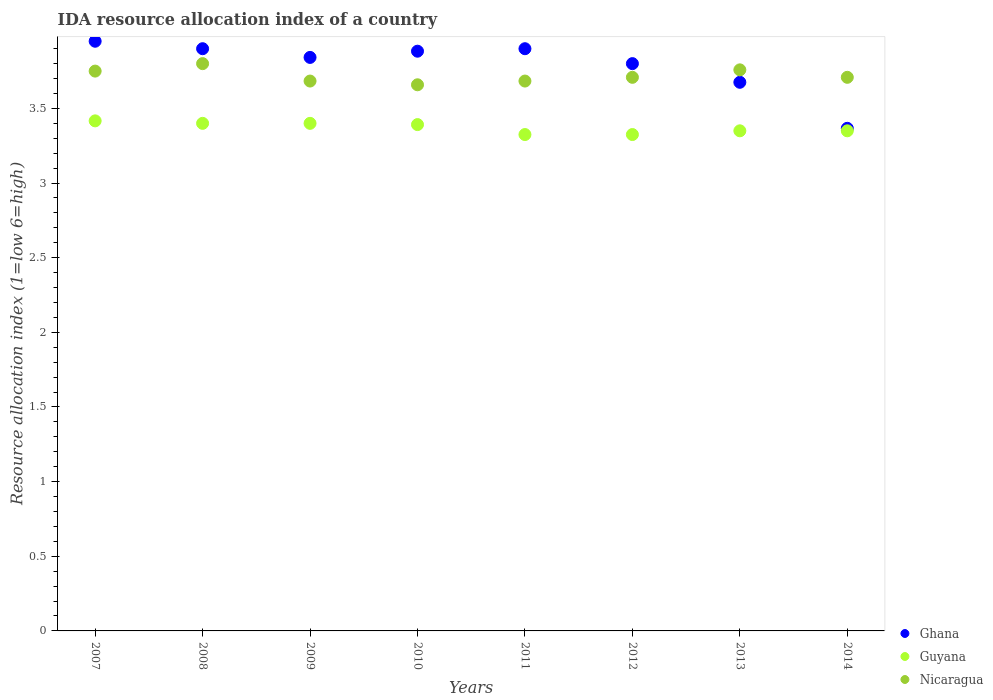Is the number of dotlines equal to the number of legend labels?
Provide a succinct answer. Yes. What is the IDA resource allocation index in Ghana in 2007?
Give a very brief answer. 3.95. Across all years, what is the maximum IDA resource allocation index in Ghana?
Make the answer very short. 3.95. Across all years, what is the minimum IDA resource allocation index in Guyana?
Keep it short and to the point. 3.33. In which year was the IDA resource allocation index in Nicaragua maximum?
Keep it short and to the point. 2008. In which year was the IDA resource allocation index in Nicaragua minimum?
Offer a very short reply. 2010. What is the total IDA resource allocation index in Nicaragua in the graph?
Provide a succinct answer. 29.75. What is the difference between the IDA resource allocation index in Nicaragua in 2012 and that in 2013?
Keep it short and to the point. -0.05. What is the difference between the IDA resource allocation index in Nicaragua in 2011 and the IDA resource allocation index in Ghana in 2013?
Offer a very short reply. 0.01. What is the average IDA resource allocation index in Nicaragua per year?
Make the answer very short. 3.72. In the year 2007, what is the difference between the IDA resource allocation index in Guyana and IDA resource allocation index in Nicaragua?
Your answer should be compact. -0.33. In how many years, is the IDA resource allocation index in Nicaragua greater than 3.2?
Provide a short and direct response. 8. What is the ratio of the IDA resource allocation index in Guyana in 2010 to that in 2011?
Give a very brief answer. 1.02. Is the IDA resource allocation index in Ghana in 2008 less than that in 2012?
Your answer should be compact. No. What is the difference between the highest and the second highest IDA resource allocation index in Nicaragua?
Offer a terse response. 0.04. What is the difference between the highest and the lowest IDA resource allocation index in Guyana?
Provide a short and direct response. 0.09. In how many years, is the IDA resource allocation index in Guyana greater than the average IDA resource allocation index in Guyana taken over all years?
Offer a very short reply. 4. Is it the case that in every year, the sum of the IDA resource allocation index in Nicaragua and IDA resource allocation index in Guyana  is greater than the IDA resource allocation index in Ghana?
Make the answer very short. Yes. Is the IDA resource allocation index in Nicaragua strictly greater than the IDA resource allocation index in Ghana over the years?
Your answer should be compact. No. Is the IDA resource allocation index in Nicaragua strictly less than the IDA resource allocation index in Guyana over the years?
Provide a short and direct response. No. How many dotlines are there?
Ensure brevity in your answer.  3. Are the values on the major ticks of Y-axis written in scientific E-notation?
Keep it short and to the point. No. Does the graph contain any zero values?
Ensure brevity in your answer.  No. Where does the legend appear in the graph?
Your answer should be compact. Bottom right. How are the legend labels stacked?
Keep it short and to the point. Vertical. What is the title of the graph?
Your answer should be compact. IDA resource allocation index of a country. What is the label or title of the X-axis?
Your answer should be very brief. Years. What is the label or title of the Y-axis?
Provide a short and direct response. Resource allocation index (1=low 6=high). What is the Resource allocation index (1=low 6=high) of Ghana in 2007?
Your response must be concise. 3.95. What is the Resource allocation index (1=low 6=high) of Guyana in 2007?
Ensure brevity in your answer.  3.42. What is the Resource allocation index (1=low 6=high) of Nicaragua in 2007?
Your response must be concise. 3.75. What is the Resource allocation index (1=low 6=high) of Ghana in 2008?
Provide a succinct answer. 3.9. What is the Resource allocation index (1=low 6=high) in Guyana in 2008?
Offer a terse response. 3.4. What is the Resource allocation index (1=low 6=high) of Nicaragua in 2008?
Your answer should be very brief. 3.8. What is the Resource allocation index (1=low 6=high) of Ghana in 2009?
Offer a very short reply. 3.84. What is the Resource allocation index (1=low 6=high) of Nicaragua in 2009?
Give a very brief answer. 3.68. What is the Resource allocation index (1=low 6=high) in Ghana in 2010?
Make the answer very short. 3.88. What is the Resource allocation index (1=low 6=high) of Guyana in 2010?
Keep it short and to the point. 3.39. What is the Resource allocation index (1=low 6=high) of Nicaragua in 2010?
Offer a terse response. 3.66. What is the Resource allocation index (1=low 6=high) of Ghana in 2011?
Offer a terse response. 3.9. What is the Resource allocation index (1=low 6=high) in Guyana in 2011?
Provide a short and direct response. 3.33. What is the Resource allocation index (1=low 6=high) in Nicaragua in 2011?
Offer a terse response. 3.68. What is the Resource allocation index (1=low 6=high) of Ghana in 2012?
Your answer should be very brief. 3.8. What is the Resource allocation index (1=low 6=high) of Guyana in 2012?
Ensure brevity in your answer.  3.33. What is the Resource allocation index (1=low 6=high) in Nicaragua in 2012?
Offer a very short reply. 3.71. What is the Resource allocation index (1=low 6=high) of Ghana in 2013?
Offer a terse response. 3.67. What is the Resource allocation index (1=low 6=high) in Guyana in 2013?
Keep it short and to the point. 3.35. What is the Resource allocation index (1=low 6=high) in Nicaragua in 2013?
Provide a short and direct response. 3.76. What is the Resource allocation index (1=low 6=high) of Ghana in 2014?
Your answer should be very brief. 3.37. What is the Resource allocation index (1=low 6=high) of Guyana in 2014?
Your answer should be very brief. 3.35. What is the Resource allocation index (1=low 6=high) of Nicaragua in 2014?
Your answer should be very brief. 3.71. Across all years, what is the maximum Resource allocation index (1=low 6=high) of Ghana?
Offer a very short reply. 3.95. Across all years, what is the maximum Resource allocation index (1=low 6=high) in Guyana?
Your response must be concise. 3.42. Across all years, what is the minimum Resource allocation index (1=low 6=high) in Ghana?
Provide a succinct answer. 3.37. Across all years, what is the minimum Resource allocation index (1=low 6=high) of Guyana?
Provide a short and direct response. 3.33. Across all years, what is the minimum Resource allocation index (1=low 6=high) in Nicaragua?
Offer a terse response. 3.66. What is the total Resource allocation index (1=low 6=high) of Ghana in the graph?
Ensure brevity in your answer.  30.32. What is the total Resource allocation index (1=low 6=high) in Guyana in the graph?
Offer a very short reply. 26.96. What is the total Resource allocation index (1=low 6=high) in Nicaragua in the graph?
Your answer should be very brief. 29.75. What is the difference between the Resource allocation index (1=low 6=high) of Guyana in 2007 and that in 2008?
Provide a succinct answer. 0.02. What is the difference between the Resource allocation index (1=low 6=high) in Ghana in 2007 and that in 2009?
Provide a short and direct response. 0.11. What is the difference between the Resource allocation index (1=low 6=high) of Guyana in 2007 and that in 2009?
Offer a very short reply. 0.02. What is the difference between the Resource allocation index (1=low 6=high) in Nicaragua in 2007 and that in 2009?
Your answer should be very brief. 0.07. What is the difference between the Resource allocation index (1=low 6=high) in Ghana in 2007 and that in 2010?
Keep it short and to the point. 0.07. What is the difference between the Resource allocation index (1=low 6=high) in Guyana in 2007 and that in 2010?
Offer a terse response. 0.03. What is the difference between the Resource allocation index (1=low 6=high) of Nicaragua in 2007 and that in 2010?
Make the answer very short. 0.09. What is the difference between the Resource allocation index (1=low 6=high) in Guyana in 2007 and that in 2011?
Give a very brief answer. 0.09. What is the difference between the Resource allocation index (1=low 6=high) in Nicaragua in 2007 and that in 2011?
Your response must be concise. 0.07. What is the difference between the Resource allocation index (1=low 6=high) in Guyana in 2007 and that in 2012?
Your answer should be very brief. 0.09. What is the difference between the Resource allocation index (1=low 6=high) in Nicaragua in 2007 and that in 2012?
Your response must be concise. 0.04. What is the difference between the Resource allocation index (1=low 6=high) in Ghana in 2007 and that in 2013?
Ensure brevity in your answer.  0.28. What is the difference between the Resource allocation index (1=low 6=high) of Guyana in 2007 and that in 2013?
Offer a terse response. 0.07. What is the difference between the Resource allocation index (1=low 6=high) of Nicaragua in 2007 and that in 2013?
Keep it short and to the point. -0.01. What is the difference between the Resource allocation index (1=low 6=high) in Ghana in 2007 and that in 2014?
Your response must be concise. 0.58. What is the difference between the Resource allocation index (1=low 6=high) in Guyana in 2007 and that in 2014?
Your answer should be very brief. 0.07. What is the difference between the Resource allocation index (1=low 6=high) of Nicaragua in 2007 and that in 2014?
Provide a short and direct response. 0.04. What is the difference between the Resource allocation index (1=low 6=high) of Ghana in 2008 and that in 2009?
Give a very brief answer. 0.06. What is the difference between the Resource allocation index (1=low 6=high) in Guyana in 2008 and that in 2009?
Provide a short and direct response. 0. What is the difference between the Resource allocation index (1=low 6=high) of Nicaragua in 2008 and that in 2009?
Provide a succinct answer. 0.12. What is the difference between the Resource allocation index (1=low 6=high) of Ghana in 2008 and that in 2010?
Provide a succinct answer. 0.02. What is the difference between the Resource allocation index (1=low 6=high) in Guyana in 2008 and that in 2010?
Offer a terse response. 0.01. What is the difference between the Resource allocation index (1=low 6=high) of Nicaragua in 2008 and that in 2010?
Ensure brevity in your answer.  0.14. What is the difference between the Resource allocation index (1=low 6=high) in Guyana in 2008 and that in 2011?
Provide a short and direct response. 0.07. What is the difference between the Resource allocation index (1=low 6=high) of Nicaragua in 2008 and that in 2011?
Your answer should be compact. 0.12. What is the difference between the Resource allocation index (1=low 6=high) in Guyana in 2008 and that in 2012?
Ensure brevity in your answer.  0.07. What is the difference between the Resource allocation index (1=low 6=high) of Nicaragua in 2008 and that in 2012?
Keep it short and to the point. 0.09. What is the difference between the Resource allocation index (1=low 6=high) in Ghana in 2008 and that in 2013?
Give a very brief answer. 0.23. What is the difference between the Resource allocation index (1=low 6=high) of Nicaragua in 2008 and that in 2013?
Offer a very short reply. 0.04. What is the difference between the Resource allocation index (1=low 6=high) of Ghana in 2008 and that in 2014?
Ensure brevity in your answer.  0.53. What is the difference between the Resource allocation index (1=low 6=high) of Guyana in 2008 and that in 2014?
Offer a very short reply. 0.05. What is the difference between the Resource allocation index (1=low 6=high) in Nicaragua in 2008 and that in 2014?
Give a very brief answer. 0.09. What is the difference between the Resource allocation index (1=low 6=high) of Ghana in 2009 and that in 2010?
Keep it short and to the point. -0.04. What is the difference between the Resource allocation index (1=low 6=high) of Guyana in 2009 and that in 2010?
Keep it short and to the point. 0.01. What is the difference between the Resource allocation index (1=low 6=high) of Nicaragua in 2009 and that in 2010?
Your answer should be compact. 0.03. What is the difference between the Resource allocation index (1=low 6=high) of Ghana in 2009 and that in 2011?
Your answer should be compact. -0.06. What is the difference between the Resource allocation index (1=low 6=high) in Guyana in 2009 and that in 2011?
Offer a very short reply. 0.07. What is the difference between the Resource allocation index (1=low 6=high) in Ghana in 2009 and that in 2012?
Offer a very short reply. 0.04. What is the difference between the Resource allocation index (1=low 6=high) of Guyana in 2009 and that in 2012?
Give a very brief answer. 0.07. What is the difference between the Resource allocation index (1=low 6=high) of Nicaragua in 2009 and that in 2012?
Provide a short and direct response. -0.03. What is the difference between the Resource allocation index (1=low 6=high) in Ghana in 2009 and that in 2013?
Provide a succinct answer. 0.17. What is the difference between the Resource allocation index (1=low 6=high) in Guyana in 2009 and that in 2013?
Your response must be concise. 0.05. What is the difference between the Resource allocation index (1=low 6=high) in Nicaragua in 2009 and that in 2013?
Your answer should be compact. -0.07. What is the difference between the Resource allocation index (1=low 6=high) in Ghana in 2009 and that in 2014?
Give a very brief answer. 0.47. What is the difference between the Resource allocation index (1=low 6=high) in Guyana in 2009 and that in 2014?
Your response must be concise. 0.05. What is the difference between the Resource allocation index (1=low 6=high) in Nicaragua in 2009 and that in 2014?
Provide a succinct answer. -0.03. What is the difference between the Resource allocation index (1=low 6=high) in Ghana in 2010 and that in 2011?
Your response must be concise. -0.02. What is the difference between the Resource allocation index (1=low 6=high) of Guyana in 2010 and that in 2011?
Give a very brief answer. 0.07. What is the difference between the Resource allocation index (1=low 6=high) in Nicaragua in 2010 and that in 2011?
Keep it short and to the point. -0.03. What is the difference between the Resource allocation index (1=low 6=high) in Ghana in 2010 and that in 2012?
Provide a short and direct response. 0.08. What is the difference between the Resource allocation index (1=low 6=high) of Guyana in 2010 and that in 2012?
Offer a very short reply. 0.07. What is the difference between the Resource allocation index (1=low 6=high) of Nicaragua in 2010 and that in 2012?
Your answer should be very brief. -0.05. What is the difference between the Resource allocation index (1=low 6=high) in Ghana in 2010 and that in 2013?
Your answer should be very brief. 0.21. What is the difference between the Resource allocation index (1=low 6=high) of Guyana in 2010 and that in 2013?
Make the answer very short. 0.04. What is the difference between the Resource allocation index (1=low 6=high) of Nicaragua in 2010 and that in 2013?
Your answer should be very brief. -0.1. What is the difference between the Resource allocation index (1=low 6=high) of Ghana in 2010 and that in 2014?
Ensure brevity in your answer.  0.52. What is the difference between the Resource allocation index (1=low 6=high) in Guyana in 2010 and that in 2014?
Your response must be concise. 0.04. What is the difference between the Resource allocation index (1=low 6=high) of Nicaragua in 2010 and that in 2014?
Make the answer very short. -0.05. What is the difference between the Resource allocation index (1=low 6=high) of Ghana in 2011 and that in 2012?
Make the answer very short. 0.1. What is the difference between the Resource allocation index (1=low 6=high) of Guyana in 2011 and that in 2012?
Offer a terse response. 0. What is the difference between the Resource allocation index (1=low 6=high) in Nicaragua in 2011 and that in 2012?
Your response must be concise. -0.03. What is the difference between the Resource allocation index (1=low 6=high) of Ghana in 2011 and that in 2013?
Keep it short and to the point. 0.23. What is the difference between the Resource allocation index (1=low 6=high) in Guyana in 2011 and that in 2013?
Provide a short and direct response. -0.03. What is the difference between the Resource allocation index (1=low 6=high) of Nicaragua in 2011 and that in 2013?
Ensure brevity in your answer.  -0.07. What is the difference between the Resource allocation index (1=low 6=high) of Ghana in 2011 and that in 2014?
Keep it short and to the point. 0.53. What is the difference between the Resource allocation index (1=low 6=high) in Guyana in 2011 and that in 2014?
Your answer should be very brief. -0.03. What is the difference between the Resource allocation index (1=low 6=high) in Nicaragua in 2011 and that in 2014?
Ensure brevity in your answer.  -0.03. What is the difference between the Resource allocation index (1=low 6=high) of Guyana in 2012 and that in 2013?
Provide a short and direct response. -0.03. What is the difference between the Resource allocation index (1=low 6=high) in Ghana in 2012 and that in 2014?
Provide a succinct answer. 0.43. What is the difference between the Resource allocation index (1=low 6=high) in Guyana in 2012 and that in 2014?
Your answer should be very brief. -0.03. What is the difference between the Resource allocation index (1=low 6=high) of Nicaragua in 2012 and that in 2014?
Your answer should be very brief. -0. What is the difference between the Resource allocation index (1=low 6=high) in Ghana in 2013 and that in 2014?
Your response must be concise. 0.31. What is the difference between the Resource allocation index (1=low 6=high) of Guyana in 2013 and that in 2014?
Your answer should be compact. 0. What is the difference between the Resource allocation index (1=low 6=high) in Ghana in 2007 and the Resource allocation index (1=low 6=high) in Guyana in 2008?
Give a very brief answer. 0.55. What is the difference between the Resource allocation index (1=low 6=high) in Guyana in 2007 and the Resource allocation index (1=low 6=high) in Nicaragua in 2008?
Your answer should be very brief. -0.38. What is the difference between the Resource allocation index (1=low 6=high) of Ghana in 2007 and the Resource allocation index (1=low 6=high) of Guyana in 2009?
Your response must be concise. 0.55. What is the difference between the Resource allocation index (1=low 6=high) in Ghana in 2007 and the Resource allocation index (1=low 6=high) in Nicaragua in 2009?
Give a very brief answer. 0.27. What is the difference between the Resource allocation index (1=low 6=high) of Guyana in 2007 and the Resource allocation index (1=low 6=high) of Nicaragua in 2009?
Your response must be concise. -0.27. What is the difference between the Resource allocation index (1=low 6=high) in Ghana in 2007 and the Resource allocation index (1=low 6=high) in Guyana in 2010?
Offer a very short reply. 0.56. What is the difference between the Resource allocation index (1=low 6=high) in Ghana in 2007 and the Resource allocation index (1=low 6=high) in Nicaragua in 2010?
Your answer should be compact. 0.29. What is the difference between the Resource allocation index (1=low 6=high) of Guyana in 2007 and the Resource allocation index (1=low 6=high) of Nicaragua in 2010?
Provide a succinct answer. -0.24. What is the difference between the Resource allocation index (1=low 6=high) of Ghana in 2007 and the Resource allocation index (1=low 6=high) of Guyana in 2011?
Make the answer very short. 0.62. What is the difference between the Resource allocation index (1=low 6=high) in Ghana in 2007 and the Resource allocation index (1=low 6=high) in Nicaragua in 2011?
Provide a succinct answer. 0.27. What is the difference between the Resource allocation index (1=low 6=high) in Guyana in 2007 and the Resource allocation index (1=low 6=high) in Nicaragua in 2011?
Your answer should be compact. -0.27. What is the difference between the Resource allocation index (1=low 6=high) of Ghana in 2007 and the Resource allocation index (1=low 6=high) of Guyana in 2012?
Provide a succinct answer. 0.62. What is the difference between the Resource allocation index (1=low 6=high) in Ghana in 2007 and the Resource allocation index (1=low 6=high) in Nicaragua in 2012?
Provide a succinct answer. 0.24. What is the difference between the Resource allocation index (1=low 6=high) of Guyana in 2007 and the Resource allocation index (1=low 6=high) of Nicaragua in 2012?
Your response must be concise. -0.29. What is the difference between the Resource allocation index (1=low 6=high) in Ghana in 2007 and the Resource allocation index (1=low 6=high) in Nicaragua in 2013?
Ensure brevity in your answer.  0.19. What is the difference between the Resource allocation index (1=low 6=high) of Guyana in 2007 and the Resource allocation index (1=low 6=high) of Nicaragua in 2013?
Provide a succinct answer. -0.34. What is the difference between the Resource allocation index (1=low 6=high) of Ghana in 2007 and the Resource allocation index (1=low 6=high) of Guyana in 2014?
Your response must be concise. 0.6. What is the difference between the Resource allocation index (1=low 6=high) in Ghana in 2007 and the Resource allocation index (1=low 6=high) in Nicaragua in 2014?
Give a very brief answer. 0.24. What is the difference between the Resource allocation index (1=low 6=high) in Guyana in 2007 and the Resource allocation index (1=low 6=high) in Nicaragua in 2014?
Offer a very short reply. -0.29. What is the difference between the Resource allocation index (1=low 6=high) in Ghana in 2008 and the Resource allocation index (1=low 6=high) in Nicaragua in 2009?
Provide a short and direct response. 0.22. What is the difference between the Resource allocation index (1=low 6=high) of Guyana in 2008 and the Resource allocation index (1=low 6=high) of Nicaragua in 2009?
Make the answer very short. -0.28. What is the difference between the Resource allocation index (1=low 6=high) of Ghana in 2008 and the Resource allocation index (1=low 6=high) of Guyana in 2010?
Give a very brief answer. 0.51. What is the difference between the Resource allocation index (1=low 6=high) in Ghana in 2008 and the Resource allocation index (1=low 6=high) in Nicaragua in 2010?
Offer a very short reply. 0.24. What is the difference between the Resource allocation index (1=low 6=high) of Guyana in 2008 and the Resource allocation index (1=low 6=high) of Nicaragua in 2010?
Give a very brief answer. -0.26. What is the difference between the Resource allocation index (1=low 6=high) of Ghana in 2008 and the Resource allocation index (1=low 6=high) of Guyana in 2011?
Offer a very short reply. 0.57. What is the difference between the Resource allocation index (1=low 6=high) in Ghana in 2008 and the Resource allocation index (1=low 6=high) in Nicaragua in 2011?
Make the answer very short. 0.22. What is the difference between the Resource allocation index (1=low 6=high) in Guyana in 2008 and the Resource allocation index (1=low 6=high) in Nicaragua in 2011?
Your answer should be compact. -0.28. What is the difference between the Resource allocation index (1=low 6=high) of Ghana in 2008 and the Resource allocation index (1=low 6=high) of Guyana in 2012?
Your answer should be compact. 0.57. What is the difference between the Resource allocation index (1=low 6=high) of Ghana in 2008 and the Resource allocation index (1=low 6=high) of Nicaragua in 2012?
Offer a very short reply. 0.19. What is the difference between the Resource allocation index (1=low 6=high) of Guyana in 2008 and the Resource allocation index (1=low 6=high) of Nicaragua in 2012?
Keep it short and to the point. -0.31. What is the difference between the Resource allocation index (1=low 6=high) in Ghana in 2008 and the Resource allocation index (1=low 6=high) in Guyana in 2013?
Your response must be concise. 0.55. What is the difference between the Resource allocation index (1=low 6=high) in Ghana in 2008 and the Resource allocation index (1=low 6=high) in Nicaragua in 2013?
Give a very brief answer. 0.14. What is the difference between the Resource allocation index (1=low 6=high) in Guyana in 2008 and the Resource allocation index (1=low 6=high) in Nicaragua in 2013?
Your response must be concise. -0.36. What is the difference between the Resource allocation index (1=low 6=high) of Ghana in 2008 and the Resource allocation index (1=low 6=high) of Guyana in 2014?
Your answer should be compact. 0.55. What is the difference between the Resource allocation index (1=low 6=high) in Ghana in 2008 and the Resource allocation index (1=low 6=high) in Nicaragua in 2014?
Provide a short and direct response. 0.19. What is the difference between the Resource allocation index (1=low 6=high) of Guyana in 2008 and the Resource allocation index (1=low 6=high) of Nicaragua in 2014?
Your answer should be very brief. -0.31. What is the difference between the Resource allocation index (1=low 6=high) in Ghana in 2009 and the Resource allocation index (1=low 6=high) in Guyana in 2010?
Keep it short and to the point. 0.45. What is the difference between the Resource allocation index (1=low 6=high) of Ghana in 2009 and the Resource allocation index (1=low 6=high) of Nicaragua in 2010?
Provide a short and direct response. 0.18. What is the difference between the Resource allocation index (1=low 6=high) in Guyana in 2009 and the Resource allocation index (1=low 6=high) in Nicaragua in 2010?
Your answer should be compact. -0.26. What is the difference between the Resource allocation index (1=low 6=high) of Ghana in 2009 and the Resource allocation index (1=low 6=high) of Guyana in 2011?
Offer a terse response. 0.52. What is the difference between the Resource allocation index (1=low 6=high) in Ghana in 2009 and the Resource allocation index (1=low 6=high) in Nicaragua in 2011?
Your answer should be very brief. 0.16. What is the difference between the Resource allocation index (1=low 6=high) in Guyana in 2009 and the Resource allocation index (1=low 6=high) in Nicaragua in 2011?
Offer a very short reply. -0.28. What is the difference between the Resource allocation index (1=low 6=high) in Ghana in 2009 and the Resource allocation index (1=low 6=high) in Guyana in 2012?
Ensure brevity in your answer.  0.52. What is the difference between the Resource allocation index (1=low 6=high) of Ghana in 2009 and the Resource allocation index (1=low 6=high) of Nicaragua in 2012?
Your answer should be compact. 0.13. What is the difference between the Resource allocation index (1=low 6=high) of Guyana in 2009 and the Resource allocation index (1=low 6=high) of Nicaragua in 2012?
Offer a very short reply. -0.31. What is the difference between the Resource allocation index (1=low 6=high) of Ghana in 2009 and the Resource allocation index (1=low 6=high) of Guyana in 2013?
Your answer should be very brief. 0.49. What is the difference between the Resource allocation index (1=low 6=high) of Ghana in 2009 and the Resource allocation index (1=low 6=high) of Nicaragua in 2013?
Offer a very short reply. 0.08. What is the difference between the Resource allocation index (1=low 6=high) of Guyana in 2009 and the Resource allocation index (1=low 6=high) of Nicaragua in 2013?
Your response must be concise. -0.36. What is the difference between the Resource allocation index (1=low 6=high) of Ghana in 2009 and the Resource allocation index (1=low 6=high) of Guyana in 2014?
Your answer should be compact. 0.49. What is the difference between the Resource allocation index (1=low 6=high) in Ghana in 2009 and the Resource allocation index (1=low 6=high) in Nicaragua in 2014?
Offer a terse response. 0.13. What is the difference between the Resource allocation index (1=low 6=high) in Guyana in 2009 and the Resource allocation index (1=low 6=high) in Nicaragua in 2014?
Your answer should be compact. -0.31. What is the difference between the Resource allocation index (1=low 6=high) in Ghana in 2010 and the Resource allocation index (1=low 6=high) in Guyana in 2011?
Give a very brief answer. 0.56. What is the difference between the Resource allocation index (1=low 6=high) in Guyana in 2010 and the Resource allocation index (1=low 6=high) in Nicaragua in 2011?
Your answer should be compact. -0.29. What is the difference between the Resource allocation index (1=low 6=high) in Ghana in 2010 and the Resource allocation index (1=low 6=high) in Guyana in 2012?
Your answer should be very brief. 0.56. What is the difference between the Resource allocation index (1=low 6=high) of Ghana in 2010 and the Resource allocation index (1=low 6=high) of Nicaragua in 2012?
Make the answer very short. 0.17. What is the difference between the Resource allocation index (1=low 6=high) in Guyana in 2010 and the Resource allocation index (1=low 6=high) in Nicaragua in 2012?
Your answer should be compact. -0.32. What is the difference between the Resource allocation index (1=low 6=high) in Ghana in 2010 and the Resource allocation index (1=low 6=high) in Guyana in 2013?
Your answer should be very brief. 0.53. What is the difference between the Resource allocation index (1=low 6=high) in Ghana in 2010 and the Resource allocation index (1=low 6=high) in Nicaragua in 2013?
Provide a short and direct response. 0.12. What is the difference between the Resource allocation index (1=low 6=high) of Guyana in 2010 and the Resource allocation index (1=low 6=high) of Nicaragua in 2013?
Ensure brevity in your answer.  -0.37. What is the difference between the Resource allocation index (1=low 6=high) of Ghana in 2010 and the Resource allocation index (1=low 6=high) of Guyana in 2014?
Provide a succinct answer. 0.53. What is the difference between the Resource allocation index (1=low 6=high) of Ghana in 2010 and the Resource allocation index (1=low 6=high) of Nicaragua in 2014?
Ensure brevity in your answer.  0.17. What is the difference between the Resource allocation index (1=low 6=high) in Guyana in 2010 and the Resource allocation index (1=low 6=high) in Nicaragua in 2014?
Make the answer very short. -0.32. What is the difference between the Resource allocation index (1=low 6=high) in Ghana in 2011 and the Resource allocation index (1=low 6=high) in Guyana in 2012?
Your answer should be very brief. 0.57. What is the difference between the Resource allocation index (1=low 6=high) in Ghana in 2011 and the Resource allocation index (1=low 6=high) in Nicaragua in 2012?
Provide a short and direct response. 0.19. What is the difference between the Resource allocation index (1=low 6=high) of Guyana in 2011 and the Resource allocation index (1=low 6=high) of Nicaragua in 2012?
Provide a short and direct response. -0.38. What is the difference between the Resource allocation index (1=low 6=high) of Ghana in 2011 and the Resource allocation index (1=low 6=high) of Guyana in 2013?
Your answer should be very brief. 0.55. What is the difference between the Resource allocation index (1=low 6=high) of Ghana in 2011 and the Resource allocation index (1=low 6=high) of Nicaragua in 2013?
Offer a very short reply. 0.14. What is the difference between the Resource allocation index (1=low 6=high) in Guyana in 2011 and the Resource allocation index (1=low 6=high) in Nicaragua in 2013?
Provide a succinct answer. -0.43. What is the difference between the Resource allocation index (1=low 6=high) of Ghana in 2011 and the Resource allocation index (1=low 6=high) of Guyana in 2014?
Provide a succinct answer. 0.55. What is the difference between the Resource allocation index (1=low 6=high) in Ghana in 2011 and the Resource allocation index (1=low 6=high) in Nicaragua in 2014?
Give a very brief answer. 0.19. What is the difference between the Resource allocation index (1=low 6=high) of Guyana in 2011 and the Resource allocation index (1=low 6=high) of Nicaragua in 2014?
Give a very brief answer. -0.38. What is the difference between the Resource allocation index (1=low 6=high) of Ghana in 2012 and the Resource allocation index (1=low 6=high) of Guyana in 2013?
Provide a short and direct response. 0.45. What is the difference between the Resource allocation index (1=low 6=high) of Ghana in 2012 and the Resource allocation index (1=low 6=high) of Nicaragua in 2013?
Your response must be concise. 0.04. What is the difference between the Resource allocation index (1=low 6=high) of Guyana in 2012 and the Resource allocation index (1=low 6=high) of Nicaragua in 2013?
Offer a very short reply. -0.43. What is the difference between the Resource allocation index (1=low 6=high) in Ghana in 2012 and the Resource allocation index (1=low 6=high) in Guyana in 2014?
Offer a terse response. 0.45. What is the difference between the Resource allocation index (1=low 6=high) in Ghana in 2012 and the Resource allocation index (1=low 6=high) in Nicaragua in 2014?
Your answer should be compact. 0.09. What is the difference between the Resource allocation index (1=low 6=high) of Guyana in 2012 and the Resource allocation index (1=low 6=high) of Nicaragua in 2014?
Keep it short and to the point. -0.38. What is the difference between the Resource allocation index (1=low 6=high) in Ghana in 2013 and the Resource allocation index (1=low 6=high) in Guyana in 2014?
Offer a terse response. 0.33. What is the difference between the Resource allocation index (1=low 6=high) in Ghana in 2013 and the Resource allocation index (1=low 6=high) in Nicaragua in 2014?
Ensure brevity in your answer.  -0.03. What is the difference between the Resource allocation index (1=low 6=high) in Guyana in 2013 and the Resource allocation index (1=low 6=high) in Nicaragua in 2014?
Provide a short and direct response. -0.36. What is the average Resource allocation index (1=low 6=high) of Ghana per year?
Keep it short and to the point. 3.79. What is the average Resource allocation index (1=low 6=high) in Guyana per year?
Your response must be concise. 3.37. What is the average Resource allocation index (1=low 6=high) in Nicaragua per year?
Offer a terse response. 3.72. In the year 2007, what is the difference between the Resource allocation index (1=low 6=high) of Ghana and Resource allocation index (1=low 6=high) of Guyana?
Make the answer very short. 0.53. In the year 2007, what is the difference between the Resource allocation index (1=low 6=high) of Ghana and Resource allocation index (1=low 6=high) of Nicaragua?
Your answer should be compact. 0.2. In the year 2008, what is the difference between the Resource allocation index (1=low 6=high) of Ghana and Resource allocation index (1=low 6=high) of Guyana?
Offer a very short reply. 0.5. In the year 2008, what is the difference between the Resource allocation index (1=low 6=high) of Guyana and Resource allocation index (1=low 6=high) of Nicaragua?
Make the answer very short. -0.4. In the year 2009, what is the difference between the Resource allocation index (1=low 6=high) of Ghana and Resource allocation index (1=low 6=high) of Guyana?
Offer a very short reply. 0.44. In the year 2009, what is the difference between the Resource allocation index (1=low 6=high) of Ghana and Resource allocation index (1=low 6=high) of Nicaragua?
Your response must be concise. 0.16. In the year 2009, what is the difference between the Resource allocation index (1=low 6=high) in Guyana and Resource allocation index (1=low 6=high) in Nicaragua?
Keep it short and to the point. -0.28. In the year 2010, what is the difference between the Resource allocation index (1=low 6=high) of Ghana and Resource allocation index (1=low 6=high) of Guyana?
Keep it short and to the point. 0.49. In the year 2010, what is the difference between the Resource allocation index (1=low 6=high) of Ghana and Resource allocation index (1=low 6=high) of Nicaragua?
Ensure brevity in your answer.  0.23. In the year 2010, what is the difference between the Resource allocation index (1=low 6=high) of Guyana and Resource allocation index (1=low 6=high) of Nicaragua?
Your answer should be compact. -0.27. In the year 2011, what is the difference between the Resource allocation index (1=low 6=high) in Ghana and Resource allocation index (1=low 6=high) in Guyana?
Offer a very short reply. 0.57. In the year 2011, what is the difference between the Resource allocation index (1=low 6=high) of Ghana and Resource allocation index (1=low 6=high) of Nicaragua?
Give a very brief answer. 0.22. In the year 2011, what is the difference between the Resource allocation index (1=low 6=high) of Guyana and Resource allocation index (1=low 6=high) of Nicaragua?
Offer a terse response. -0.36. In the year 2012, what is the difference between the Resource allocation index (1=low 6=high) in Ghana and Resource allocation index (1=low 6=high) in Guyana?
Your answer should be compact. 0.47. In the year 2012, what is the difference between the Resource allocation index (1=low 6=high) in Ghana and Resource allocation index (1=low 6=high) in Nicaragua?
Offer a very short reply. 0.09. In the year 2012, what is the difference between the Resource allocation index (1=low 6=high) in Guyana and Resource allocation index (1=low 6=high) in Nicaragua?
Your answer should be very brief. -0.38. In the year 2013, what is the difference between the Resource allocation index (1=low 6=high) of Ghana and Resource allocation index (1=low 6=high) of Guyana?
Offer a terse response. 0.33. In the year 2013, what is the difference between the Resource allocation index (1=low 6=high) of Ghana and Resource allocation index (1=low 6=high) of Nicaragua?
Give a very brief answer. -0.08. In the year 2013, what is the difference between the Resource allocation index (1=low 6=high) in Guyana and Resource allocation index (1=low 6=high) in Nicaragua?
Make the answer very short. -0.41. In the year 2014, what is the difference between the Resource allocation index (1=low 6=high) in Ghana and Resource allocation index (1=low 6=high) in Guyana?
Offer a very short reply. 0.02. In the year 2014, what is the difference between the Resource allocation index (1=low 6=high) of Ghana and Resource allocation index (1=low 6=high) of Nicaragua?
Ensure brevity in your answer.  -0.34. In the year 2014, what is the difference between the Resource allocation index (1=low 6=high) of Guyana and Resource allocation index (1=low 6=high) of Nicaragua?
Make the answer very short. -0.36. What is the ratio of the Resource allocation index (1=low 6=high) in Ghana in 2007 to that in 2008?
Provide a short and direct response. 1.01. What is the ratio of the Resource allocation index (1=low 6=high) in Ghana in 2007 to that in 2009?
Give a very brief answer. 1.03. What is the ratio of the Resource allocation index (1=low 6=high) in Guyana in 2007 to that in 2009?
Ensure brevity in your answer.  1. What is the ratio of the Resource allocation index (1=low 6=high) of Nicaragua in 2007 to that in 2009?
Your answer should be very brief. 1.02. What is the ratio of the Resource allocation index (1=low 6=high) of Ghana in 2007 to that in 2010?
Provide a short and direct response. 1.02. What is the ratio of the Resource allocation index (1=low 6=high) of Guyana in 2007 to that in 2010?
Provide a short and direct response. 1.01. What is the ratio of the Resource allocation index (1=low 6=high) of Nicaragua in 2007 to that in 2010?
Ensure brevity in your answer.  1.03. What is the ratio of the Resource allocation index (1=low 6=high) in Ghana in 2007 to that in 2011?
Provide a succinct answer. 1.01. What is the ratio of the Resource allocation index (1=low 6=high) in Guyana in 2007 to that in 2011?
Give a very brief answer. 1.03. What is the ratio of the Resource allocation index (1=low 6=high) of Nicaragua in 2007 to that in 2011?
Your response must be concise. 1.02. What is the ratio of the Resource allocation index (1=low 6=high) of Ghana in 2007 to that in 2012?
Your answer should be compact. 1.04. What is the ratio of the Resource allocation index (1=low 6=high) in Guyana in 2007 to that in 2012?
Your response must be concise. 1.03. What is the ratio of the Resource allocation index (1=low 6=high) of Nicaragua in 2007 to that in 2012?
Give a very brief answer. 1.01. What is the ratio of the Resource allocation index (1=low 6=high) of Ghana in 2007 to that in 2013?
Your response must be concise. 1.07. What is the ratio of the Resource allocation index (1=low 6=high) in Guyana in 2007 to that in 2013?
Ensure brevity in your answer.  1.02. What is the ratio of the Resource allocation index (1=low 6=high) in Nicaragua in 2007 to that in 2013?
Make the answer very short. 1. What is the ratio of the Resource allocation index (1=low 6=high) in Ghana in 2007 to that in 2014?
Your answer should be compact. 1.17. What is the ratio of the Resource allocation index (1=low 6=high) of Guyana in 2007 to that in 2014?
Ensure brevity in your answer.  1.02. What is the ratio of the Resource allocation index (1=low 6=high) in Nicaragua in 2007 to that in 2014?
Give a very brief answer. 1.01. What is the ratio of the Resource allocation index (1=low 6=high) in Ghana in 2008 to that in 2009?
Your response must be concise. 1.02. What is the ratio of the Resource allocation index (1=low 6=high) in Guyana in 2008 to that in 2009?
Ensure brevity in your answer.  1. What is the ratio of the Resource allocation index (1=low 6=high) in Nicaragua in 2008 to that in 2009?
Provide a succinct answer. 1.03. What is the ratio of the Resource allocation index (1=low 6=high) in Nicaragua in 2008 to that in 2010?
Keep it short and to the point. 1.04. What is the ratio of the Resource allocation index (1=low 6=high) in Guyana in 2008 to that in 2011?
Give a very brief answer. 1.02. What is the ratio of the Resource allocation index (1=low 6=high) of Nicaragua in 2008 to that in 2011?
Ensure brevity in your answer.  1.03. What is the ratio of the Resource allocation index (1=low 6=high) in Ghana in 2008 to that in 2012?
Ensure brevity in your answer.  1.03. What is the ratio of the Resource allocation index (1=low 6=high) in Guyana in 2008 to that in 2012?
Provide a succinct answer. 1.02. What is the ratio of the Resource allocation index (1=low 6=high) of Nicaragua in 2008 to that in 2012?
Provide a short and direct response. 1.02. What is the ratio of the Resource allocation index (1=low 6=high) in Ghana in 2008 to that in 2013?
Your answer should be compact. 1.06. What is the ratio of the Resource allocation index (1=low 6=high) in Guyana in 2008 to that in 2013?
Your answer should be compact. 1.01. What is the ratio of the Resource allocation index (1=low 6=high) in Nicaragua in 2008 to that in 2013?
Your answer should be very brief. 1.01. What is the ratio of the Resource allocation index (1=low 6=high) in Ghana in 2008 to that in 2014?
Ensure brevity in your answer.  1.16. What is the ratio of the Resource allocation index (1=low 6=high) in Guyana in 2008 to that in 2014?
Offer a very short reply. 1.01. What is the ratio of the Resource allocation index (1=low 6=high) in Nicaragua in 2008 to that in 2014?
Keep it short and to the point. 1.02. What is the ratio of the Resource allocation index (1=low 6=high) in Ghana in 2009 to that in 2010?
Offer a terse response. 0.99. What is the ratio of the Resource allocation index (1=low 6=high) of Guyana in 2009 to that in 2010?
Provide a succinct answer. 1. What is the ratio of the Resource allocation index (1=low 6=high) in Nicaragua in 2009 to that in 2010?
Keep it short and to the point. 1.01. What is the ratio of the Resource allocation index (1=low 6=high) in Ghana in 2009 to that in 2011?
Keep it short and to the point. 0.98. What is the ratio of the Resource allocation index (1=low 6=high) in Guyana in 2009 to that in 2011?
Offer a very short reply. 1.02. What is the ratio of the Resource allocation index (1=low 6=high) of Nicaragua in 2009 to that in 2011?
Keep it short and to the point. 1. What is the ratio of the Resource allocation index (1=low 6=high) in Guyana in 2009 to that in 2012?
Your answer should be very brief. 1.02. What is the ratio of the Resource allocation index (1=low 6=high) of Nicaragua in 2009 to that in 2012?
Your response must be concise. 0.99. What is the ratio of the Resource allocation index (1=low 6=high) of Ghana in 2009 to that in 2013?
Give a very brief answer. 1.05. What is the ratio of the Resource allocation index (1=low 6=high) of Guyana in 2009 to that in 2013?
Your response must be concise. 1.01. What is the ratio of the Resource allocation index (1=low 6=high) in Ghana in 2009 to that in 2014?
Your answer should be compact. 1.14. What is the ratio of the Resource allocation index (1=low 6=high) of Guyana in 2009 to that in 2014?
Give a very brief answer. 1.01. What is the ratio of the Resource allocation index (1=low 6=high) of Nicaragua in 2009 to that in 2014?
Keep it short and to the point. 0.99. What is the ratio of the Resource allocation index (1=low 6=high) of Ghana in 2010 to that in 2011?
Give a very brief answer. 1. What is the ratio of the Resource allocation index (1=low 6=high) of Guyana in 2010 to that in 2011?
Your answer should be compact. 1.02. What is the ratio of the Resource allocation index (1=low 6=high) of Ghana in 2010 to that in 2012?
Your answer should be compact. 1.02. What is the ratio of the Resource allocation index (1=low 6=high) of Guyana in 2010 to that in 2012?
Make the answer very short. 1.02. What is the ratio of the Resource allocation index (1=low 6=high) in Nicaragua in 2010 to that in 2012?
Give a very brief answer. 0.99. What is the ratio of the Resource allocation index (1=low 6=high) of Ghana in 2010 to that in 2013?
Provide a short and direct response. 1.06. What is the ratio of the Resource allocation index (1=low 6=high) in Guyana in 2010 to that in 2013?
Make the answer very short. 1.01. What is the ratio of the Resource allocation index (1=low 6=high) in Nicaragua in 2010 to that in 2013?
Keep it short and to the point. 0.97. What is the ratio of the Resource allocation index (1=low 6=high) in Ghana in 2010 to that in 2014?
Your answer should be compact. 1.15. What is the ratio of the Resource allocation index (1=low 6=high) in Guyana in 2010 to that in 2014?
Provide a succinct answer. 1.01. What is the ratio of the Resource allocation index (1=low 6=high) of Nicaragua in 2010 to that in 2014?
Give a very brief answer. 0.99. What is the ratio of the Resource allocation index (1=low 6=high) of Ghana in 2011 to that in 2012?
Ensure brevity in your answer.  1.03. What is the ratio of the Resource allocation index (1=low 6=high) of Ghana in 2011 to that in 2013?
Ensure brevity in your answer.  1.06. What is the ratio of the Resource allocation index (1=low 6=high) of Guyana in 2011 to that in 2013?
Your response must be concise. 0.99. What is the ratio of the Resource allocation index (1=low 6=high) in Ghana in 2011 to that in 2014?
Provide a succinct answer. 1.16. What is the ratio of the Resource allocation index (1=low 6=high) in Guyana in 2011 to that in 2014?
Give a very brief answer. 0.99. What is the ratio of the Resource allocation index (1=low 6=high) in Ghana in 2012 to that in 2013?
Provide a succinct answer. 1.03. What is the ratio of the Resource allocation index (1=low 6=high) in Guyana in 2012 to that in 2013?
Offer a terse response. 0.99. What is the ratio of the Resource allocation index (1=low 6=high) in Nicaragua in 2012 to that in 2013?
Offer a terse response. 0.99. What is the ratio of the Resource allocation index (1=low 6=high) in Ghana in 2012 to that in 2014?
Your response must be concise. 1.13. What is the ratio of the Resource allocation index (1=low 6=high) of Guyana in 2012 to that in 2014?
Your answer should be compact. 0.99. What is the ratio of the Resource allocation index (1=low 6=high) of Nicaragua in 2012 to that in 2014?
Your response must be concise. 1. What is the ratio of the Resource allocation index (1=low 6=high) in Ghana in 2013 to that in 2014?
Provide a short and direct response. 1.09. What is the ratio of the Resource allocation index (1=low 6=high) of Guyana in 2013 to that in 2014?
Ensure brevity in your answer.  1. What is the ratio of the Resource allocation index (1=low 6=high) of Nicaragua in 2013 to that in 2014?
Make the answer very short. 1.01. What is the difference between the highest and the second highest Resource allocation index (1=low 6=high) in Guyana?
Your response must be concise. 0.02. What is the difference between the highest and the second highest Resource allocation index (1=low 6=high) of Nicaragua?
Ensure brevity in your answer.  0.04. What is the difference between the highest and the lowest Resource allocation index (1=low 6=high) in Ghana?
Keep it short and to the point. 0.58. What is the difference between the highest and the lowest Resource allocation index (1=low 6=high) of Guyana?
Give a very brief answer. 0.09. What is the difference between the highest and the lowest Resource allocation index (1=low 6=high) of Nicaragua?
Offer a very short reply. 0.14. 